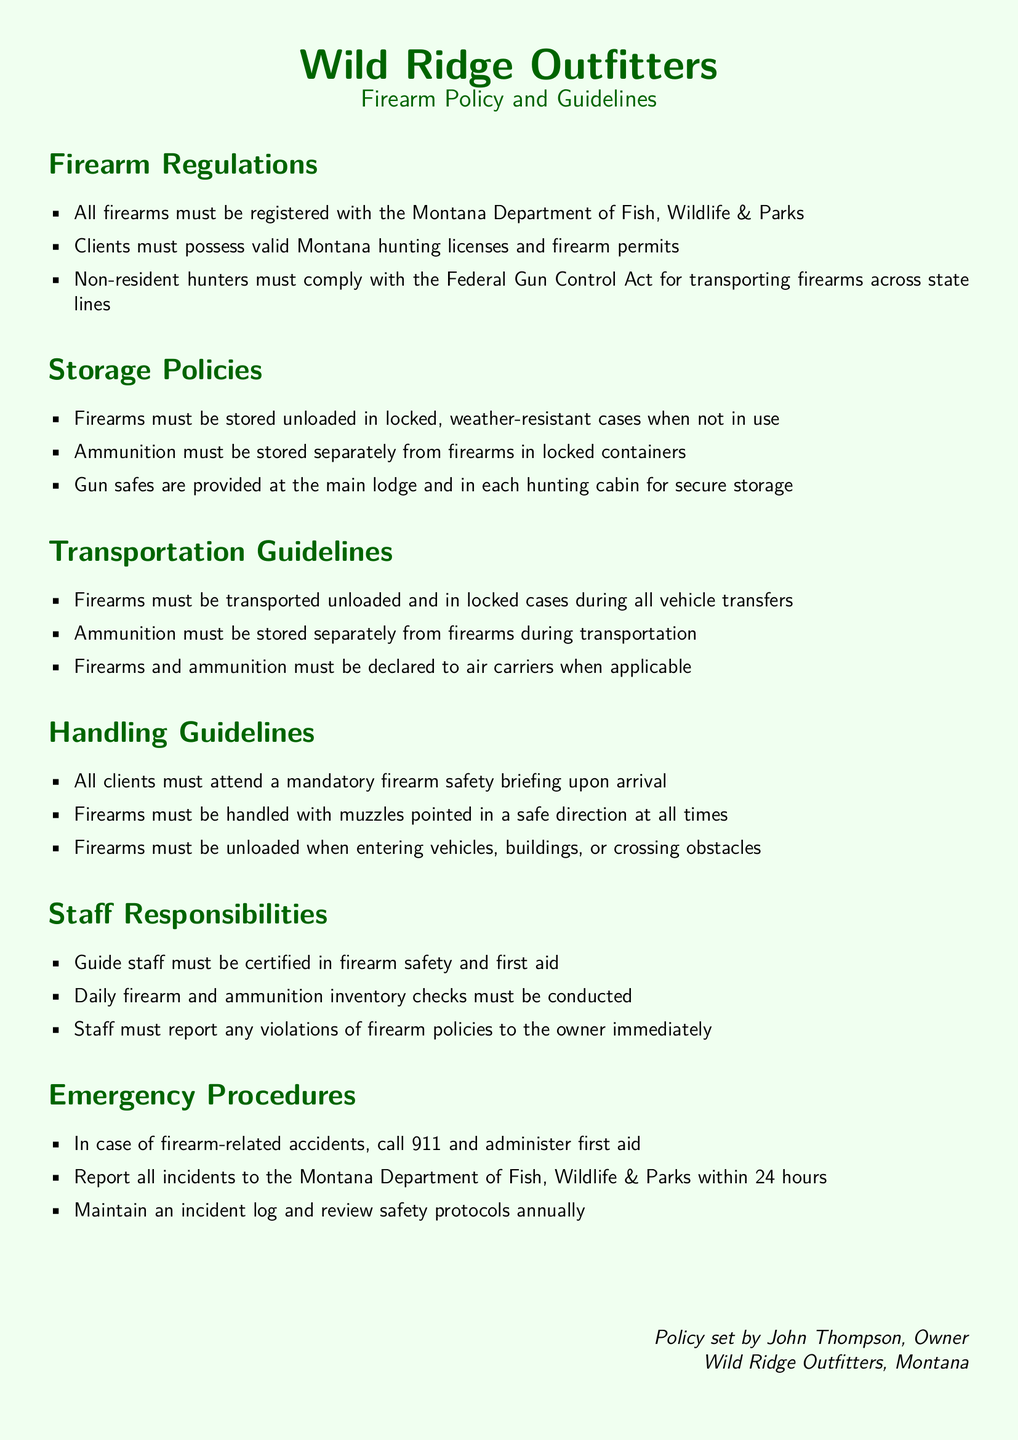What must all firearms be registered with? Firearms must be registered with the Montana Department of Fish, Wildlife & Parks.
Answer: Montana Department of Fish, Wildlife & Parks What must clients possess? Clients must possess valid Montana hunting licenses and firearm permits.
Answer: Valid Montana hunting licenses and firearm permits What is required for non-resident hunters? Non-resident hunters must comply with the Federal Gun Control Act for transporting firearms across state lines.
Answer: Federal Gun Control Act Where must firearms be stored when not in use? Firearms must be stored unloaded in locked, weather-resistant cases when not in use.
Answer: Unloaded in locked, weather-resistant cases What is the purpose of the mandatory firearm safety briefing? All clients must attend a mandatory firearm safety briefing upon arrival for safety awareness.
Answer: Safety awareness Who must conduct daily firearm and ammunition inventory checks? Staff must conduct daily firearm and ammunition inventory checks.
Answer: Staff What should be done in case of firearm-related accidents? In case of firearm-related accidents, call 911 and administer first aid.
Answer: Call 911 and administer first aid What must staff report immediately? Staff must report any violations of firearm policies to the owner immediately.
Answer: Violations of firearm policies What should be stored separately from firearms during transportation? Ammunition must be stored separately from firearms during transportation.
Answer: Ammunition 